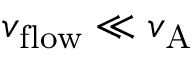<formula> <loc_0><loc_0><loc_500><loc_500>v _ { f l o w } \ll v _ { A }</formula> 